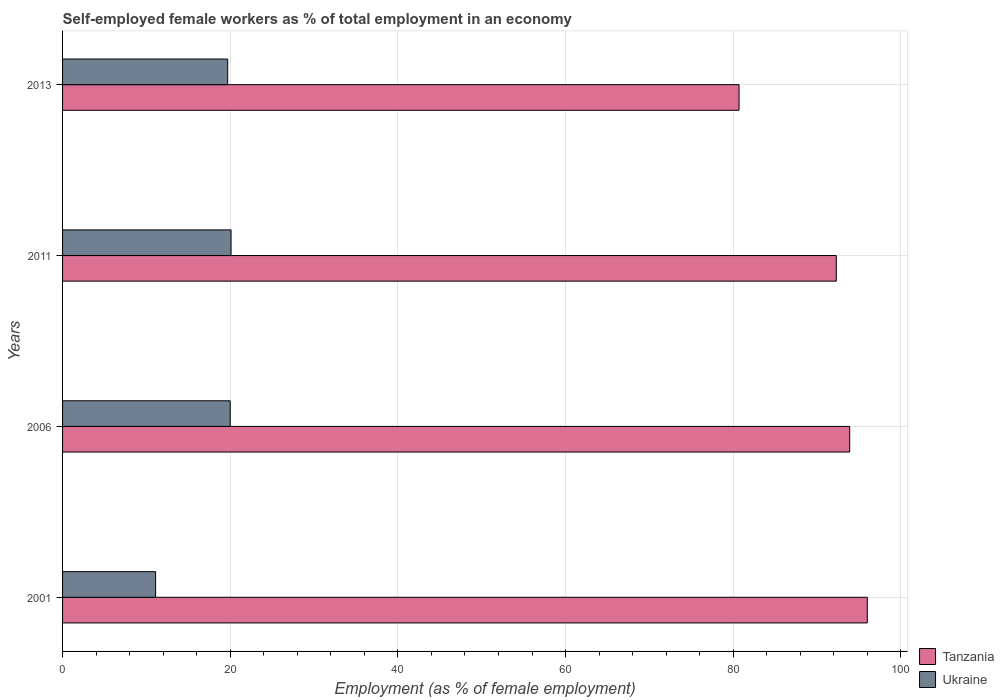How many groups of bars are there?
Offer a very short reply. 4. Are the number of bars on each tick of the Y-axis equal?
Make the answer very short. Yes. How many bars are there on the 4th tick from the bottom?
Your answer should be very brief. 2. In how many cases, is the number of bars for a given year not equal to the number of legend labels?
Give a very brief answer. 0. What is the percentage of self-employed female workers in Tanzania in 2001?
Make the answer very short. 96. Across all years, what is the maximum percentage of self-employed female workers in Ukraine?
Your answer should be very brief. 20.1. Across all years, what is the minimum percentage of self-employed female workers in Ukraine?
Your answer should be very brief. 11.1. In which year was the percentage of self-employed female workers in Tanzania minimum?
Your answer should be very brief. 2013. What is the total percentage of self-employed female workers in Ukraine in the graph?
Your answer should be compact. 70.9. What is the difference between the percentage of self-employed female workers in Ukraine in 2001 and that in 2013?
Make the answer very short. -8.6. What is the difference between the percentage of self-employed female workers in Ukraine in 2006 and the percentage of self-employed female workers in Tanzania in 2011?
Make the answer very short. -72.3. What is the average percentage of self-employed female workers in Tanzania per year?
Your response must be concise. 90.73. In the year 2001, what is the difference between the percentage of self-employed female workers in Ukraine and percentage of self-employed female workers in Tanzania?
Your answer should be very brief. -84.9. What is the ratio of the percentage of self-employed female workers in Ukraine in 2006 to that in 2013?
Your answer should be very brief. 1.02. What is the difference between the highest and the second highest percentage of self-employed female workers in Ukraine?
Your answer should be very brief. 0.1. What is the difference between the highest and the lowest percentage of self-employed female workers in Tanzania?
Offer a terse response. 15.3. In how many years, is the percentage of self-employed female workers in Tanzania greater than the average percentage of self-employed female workers in Tanzania taken over all years?
Provide a short and direct response. 3. Is the sum of the percentage of self-employed female workers in Ukraine in 2006 and 2013 greater than the maximum percentage of self-employed female workers in Tanzania across all years?
Your answer should be very brief. No. What does the 2nd bar from the top in 2013 represents?
Offer a very short reply. Tanzania. What does the 2nd bar from the bottom in 2013 represents?
Provide a succinct answer. Ukraine. Does the graph contain any zero values?
Provide a succinct answer. No. Does the graph contain grids?
Keep it short and to the point. Yes. What is the title of the graph?
Keep it short and to the point. Self-employed female workers as % of total employment in an economy. Does "Europe(all income levels)" appear as one of the legend labels in the graph?
Your answer should be very brief. No. What is the label or title of the X-axis?
Your response must be concise. Employment (as % of female employment). What is the label or title of the Y-axis?
Offer a terse response. Years. What is the Employment (as % of female employment) of Tanzania in 2001?
Offer a very short reply. 96. What is the Employment (as % of female employment) of Ukraine in 2001?
Make the answer very short. 11.1. What is the Employment (as % of female employment) of Tanzania in 2006?
Provide a succinct answer. 93.9. What is the Employment (as % of female employment) of Ukraine in 2006?
Offer a very short reply. 20. What is the Employment (as % of female employment) in Tanzania in 2011?
Ensure brevity in your answer.  92.3. What is the Employment (as % of female employment) in Ukraine in 2011?
Provide a short and direct response. 20.1. What is the Employment (as % of female employment) in Tanzania in 2013?
Give a very brief answer. 80.7. What is the Employment (as % of female employment) of Ukraine in 2013?
Offer a terse response. 19.7. Across all years, what is the maximum Employment (as % of female employment) of Tanzania?
Offer a terse response. 96. Across all years, what is the maximum Employment (as % of female employment) in Ukraine?
Give a very brief answer. 20.1. Across all years, what is the minimum Employment (as % of female employment) in Tanzania?
Ensure brevity in your answer.  80.7. Across all years, what is the minimum Employment (as % of female employment) in Ukraine?
Provide a short and direct response. 11.1. What is the total Employment (as % of female employment) in Tanzania in the graph?
Your response must be concise. 362.9. What is the total Employment (as % of female employment) in Ukraine in the graph?
Your response must be concise. 70.9. What is the difference between the Employment (as % of female employment) in Ukraine in 2001 and that in 2006?
Provide a succinct answer. -8.9. What is the difference between the Employment (as % of female employment) of Tanzania in 2001 and that in 2011?
Provide a short and direct response. 3.7. What is the difference between the Employment (as % of female employment) in Tanzania in 2001 and that in 2013?
Your answer should be very brief. 15.3. What is the difference between the Employment (as % of female employment) in Ukraine in 2006 and that in 2011?
Offer a terse response. -0.1. What is the difference between the Employment (as % of female employment) in Tanzania in 2006 and that in 2013?
Keep it short and to the point. 13.2. What is the difference between the Employment (as % of female employment) in Tanzania in 2001 and the Employment (as % of female employment) in Ukraine in 2011?
Your answer should be compact. 75.9. What is the difference between the Employment (as % of female employment) of Tanzania in 2001 and the Employment (as % of female employment) of Ukraine in 2013?
Give a very brief answer. 76.3. What is the difference between the Employment (as % of female employment) in Tanzania in 2006 and the Employment (as % of female employment) in Ukraine in 2011?
Ensure brevity in your answer.  73.8. What is the difference between the Employment (as % of female employment) of Tanzania in 2006 and the Employment (as % of female employment) of Ukraine in 2013?
Your answer should be very brief. 74.2. What is the difference between the Employment (as % of female employment) in Tanzania in 2011 and the Employment (as % of female employment) in Ukraine in 2013?
Ensure brevity in your answer.  72.6. What is the average Employment (as % of female employment) in Tanzania per year?
Make the answer very short. 90.72. What is the average Employment (as % of female employment) in Ukraine per year?
Your answer should be compact. 17.73. In the year 2001, what is the difference between the Employment (as % of female employment) in Tanzania and Employment (as % of female employment) in Ukraine?
Ensure brevity in your answer.  84.9. In the year 2006, what is the difference between the Employment (as % of female employment) of Tanzania and Employment (as % of female employment) of Ukraine?
Offer a very short reply. 73.9. In the year 2011, what is the difference between the Employment (as % of female employment) in Tanzania and Employment (as % of female employment) in Ukraine?
Keep it short and to the point. 72.2. In the year 2013, what is the difference between the Employment (as % of female employment) in Tanzania and Employment (as % of female employment) in Ukraine?
Offer a terse response. 61. What is the ratio of the Employment (as % of female employment) in Tanzania in 2001 to that in 2006?
Your answer should be very brief. 1.02. What is the ratio of the Employment (as % of female employment) of Ukraine in 2001 to that in 2006?
Your answer should be very brief. 0.56. What is the ratio of the Employment (as % of female employment) in Tanzania in 2001 to that in 2011?
Your response must be concise. 1.04. What is the ratio of the Employment (as % of female employment) of Ukraine in 2001 to that in 2011?
Ensure brevity in your answer.  0.55. What is the ratio of the Employment (as % of female employment) in Tanzania in 2001 to that in 2013?
Your answer should be compact. 1.19. What is the ratio of the Employment (as % of female employment) in Ukraine in 2001 to that in 2013?
Your answer should be very brief. 0.56. What is the ratio of the Employment (as % of female employment) of Tanzania in 2006 to that in 2011?
Provide a short and direct response. 1.02. What is the ratio of the Employment (as % of female employment) in Ukraine in 2006 to that in 2011?
Your answer should be compact. 0.99. What is the ratio of the Employment (as % of female employment) in Tanzania in 2006 to that in 2013?
Offer a terse response. 1.16. What is the ratio of the Employment (as % of female employment) of Ukraine in 2006 to that in 2013?
Ensure brevity in your answer.  1.02. What is the ratio of the Employment (as % of female employment) of Tanzania in 2011 to that in 2013?
Provide a succinct answer. 1.14. What is the ratio of the Employment (as % of female employment) of Ukraine in 2011 to that in 2013?
Keep it short and to the point. 1.02. What is the difference between the highest and the second highest Employment (as % of female employment) in Ukraine?
Give a very brief answer. 0.1. What is the difference between the highest and the lowest Employment (as % of female employment) in Tanzania?
Keep it short and to the point. 15.3. What is the difference between the highest and the lowest Employment (as % of female employment) of Ukraine?
Provide a succinct answer. 9. 